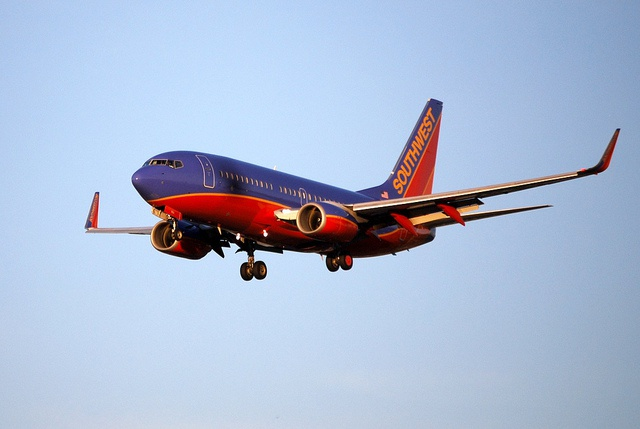Describe the objects in this image and their specific colors. I can see a airplane in lavender, black, navy, brown, and maroon tones in this image. 